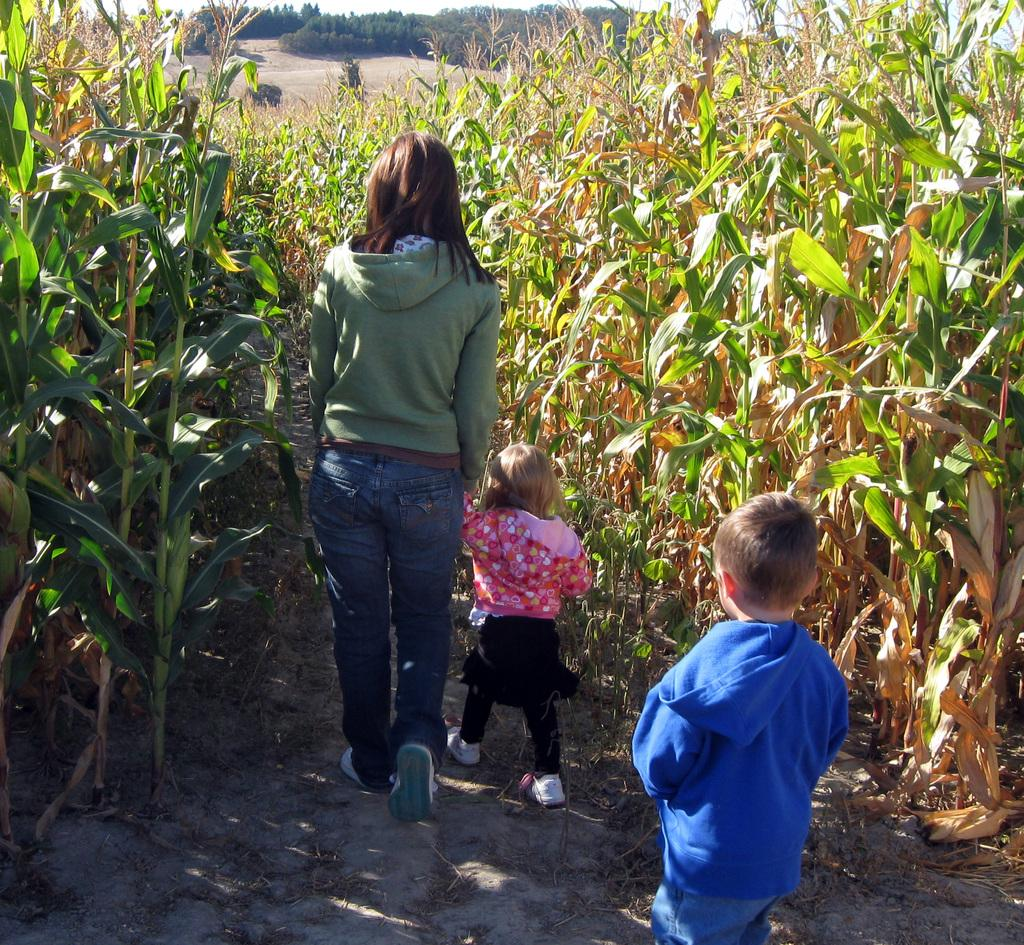How many people are in the image? There are three people in the image. What are the people doing in the image? The people are walking. Can you describe the clothing of the people in the image? The people are wearing different color dresses. What type of vegetation can be seen on both sides of the image? There are plants on both sides of the image, and they are in green and brown colors. What is visible in the background of the image? There are trees visible in the background of the image. How many passengers are sitting on the deer in the image? There are no passengers or deer present in the image. What type of salt can be seen on the plants in the image? There is no salt present in the image; it features plants and trees. 